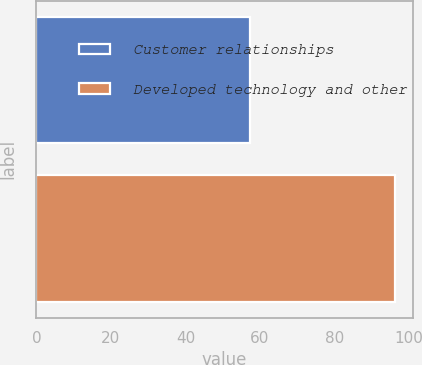Convert chart. <chart><loc_0><loc_0><loc_500><loc_500><bar_chart><fcel>Customer relationships<fcel>Developed technology and other<nl><fcel>57.2<fcel>96.2<nl></chart> 